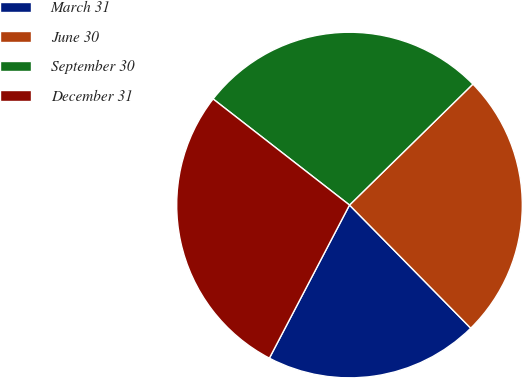Convert chart. <chart><loc_0><loc_0><loc_500><loc_500><pie_chart><fcel>March 31<fcel>June 30<fcel>September 30<fcel>December 31<nl><fcel>20.05%<fcel>24.97%<fcel>27.14%<fcel>27.85%<nl></chart> 